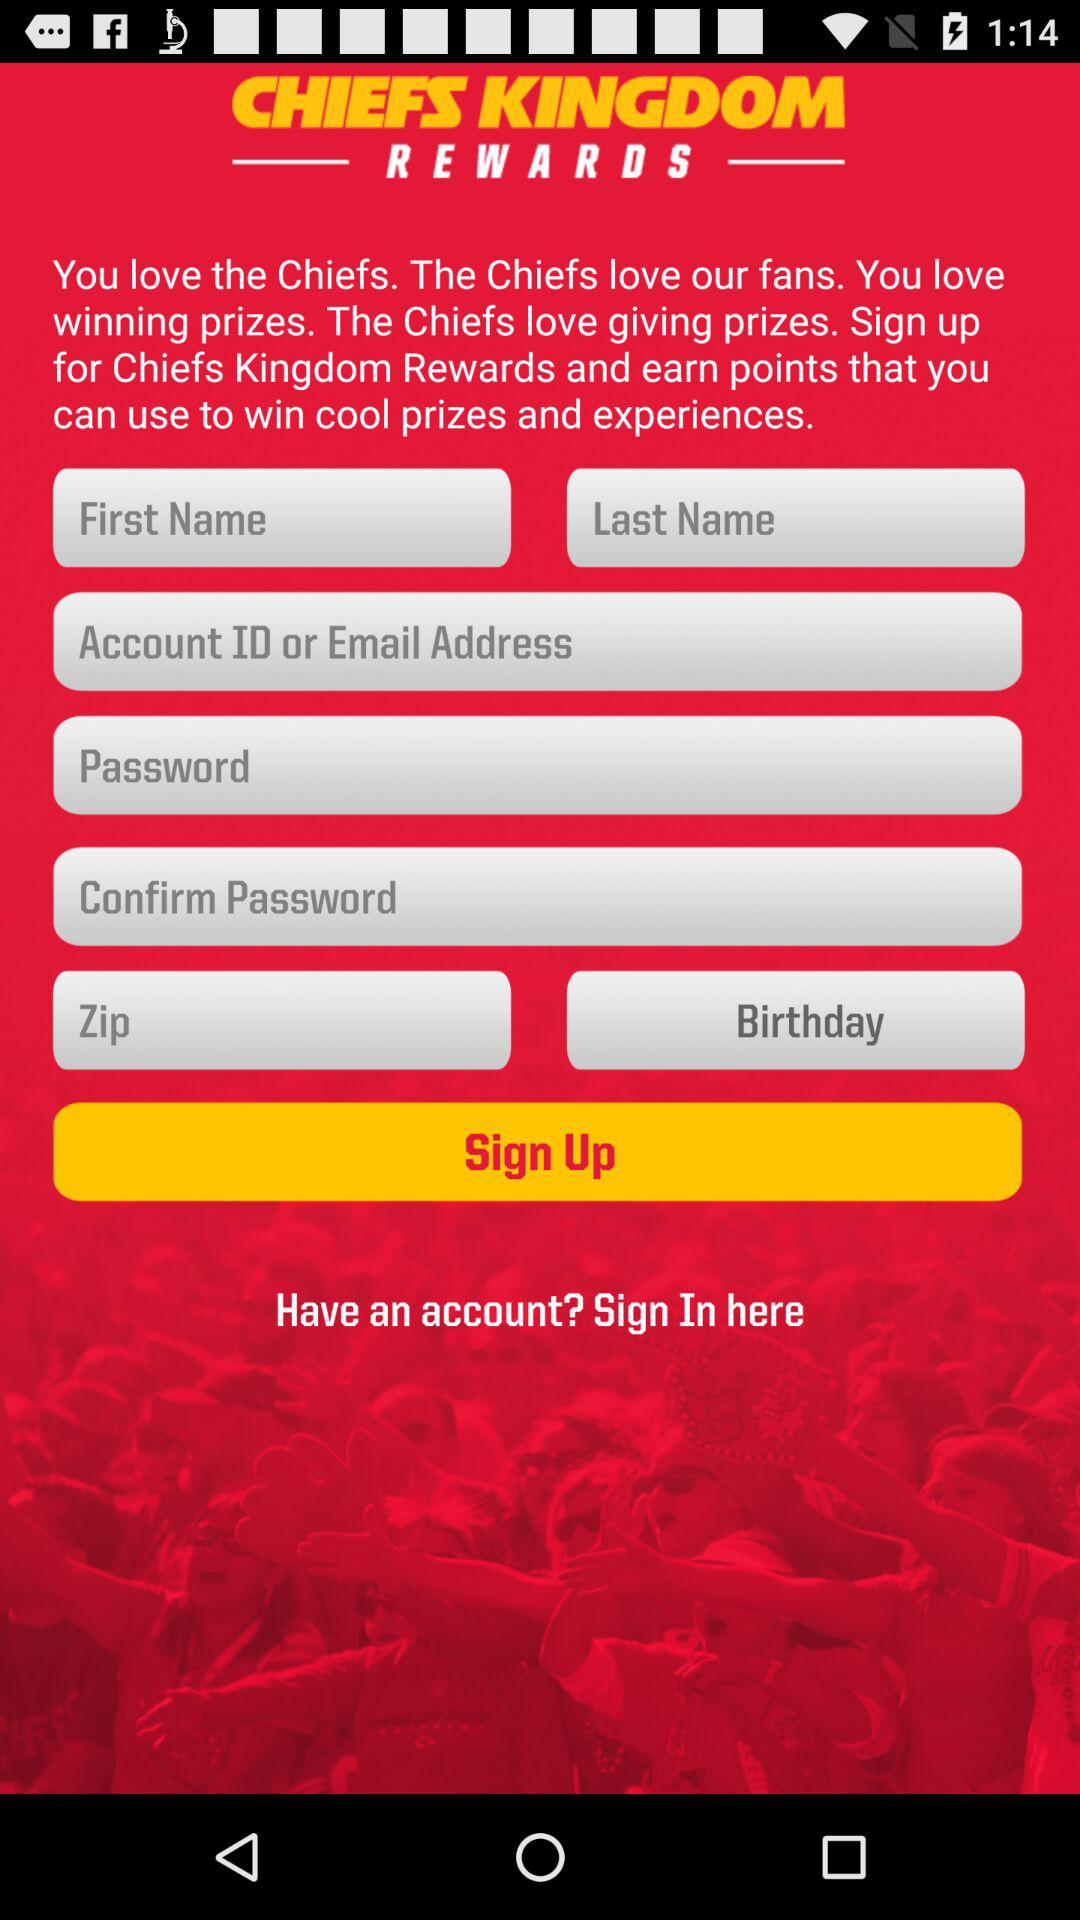What is the name of the application? The name of the application is "CHIEFS KINGDOM REWARDS". 